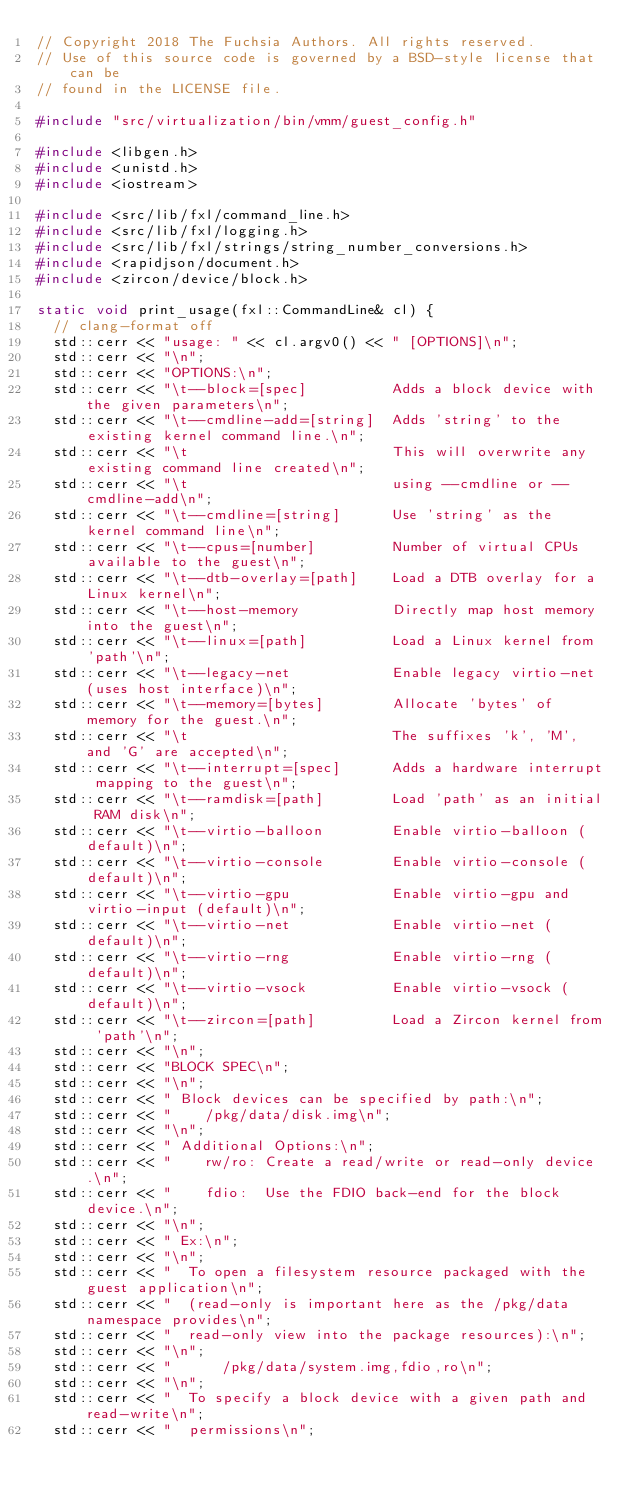Convert code to text. <code><loc_0><loc_0><loc_500><loc_500><_C++_>// Copyright 2018 The Fuchsia Authors. All rights reserved.
// Use of this source code is governed by a BSD-style license that can be
// found in the LICENSE file.

#include "src/virtualization/bin/vmm/guest_config.h"

#include <libgen.h>
#include <unistd.h>
#include <iostream>

#include <src/lib/fxl/command_line.h>
#include <src/lib/fxl/logging.h>
#include <src/lib/fxl/strings/string_number_conversions.h>
#include <rapidjson/document.h>
#include <zircon/device/block.h>

static void print_usage(fxl::CommandLine& cl) {
  // clang-format off
  std::cerr << "usage: " << cl.argv0() << " [OPTIONS]\n";
  std::cerr << "\n";
  std::cerr << "OPTIONS:\n";
  std::cerr << "\t--block=[spec]          Adds a block device with the given parameters\n";
  std::cerr << "\t--cmdline-add=[string]  Adds 'string' to the existing kernel command line.\n";
  std::cerr << "\t                        This will overwrite any existing command line created\n";
  std::cerr << "\t                        using --cmdline or --cmdline-add\n";
  std::cerr << "\t--cmdline=[string]      Use 'string' as the kernel command line\n";
  std::cerr << "\t--cpus=[number]         Number of virtual CPUs available to the guest\n";
  std::cerr << "\t--dtb-overlay=[path]    Load a DTB overlay for a Linux kernel\n";
  std::cerr << "\t--host-memory           Directly map host memory into the guest\n";
  std::cerr << "\t--linux=[path]          Load a Linux kernel from 'path'\n";
  std::cerr << "\t--legacy-net            Enable legacy virtio-net (uses host interface)\n";
  std::cerr << "\t--memory=[bytes]        Allocate 'bytes' of memory for the guest.\n";
  std::cerr << "\t                        The suffixes 'k', 'M', and 'G' are accepted\n";
  std::cerr << "\t--interrupt=[spec]      Adds a hardware interrupt mapping to the guest\n";
  std::cerr << "\t--ramdisk=[path]        Load 'path' as an initial RAM disk\n";
  std::cerr << "\t--virtio-balloon        Enable virtio-balloon (default)\n";
  std::cerr << "\t--virtio-console        Enable virtio-console (default)\n";
  std::cerr << "\t--virtio-gpu            Enable virtio-gpu and virtio-input (default)\n";
  std::cerr << "\t--virtio-net            Enable virtio-net (default)\n";
  std::cerr << "\t--virtio-rng            Enable virtio-rng (default)\n";
  std::cerr << "\t--virtio-vsock          Enable virtio-vsock (default)\n";
  std::cerr << "\t--zircon=[path]         Load a Zircon kernel from 'path'\n";
  std::cerr << "\n";
  std::cerr << "BLOCK SPEC\n";
  std::cerr << "\n";
  std::cerr << " Block devices can be specified by path:\n";
  std::cerr << "    /pkg/data/disk.img\n";
  std::cerr << "\n";
  std::cerr << " Additional Options:\n";
  std::cerr << "    rw/ro: Create a read/write or read-only device.\n";
  std::cerr << "    fdio:  Use the FDIO back-end for the block device.\n";
  std::cerr << "\n";
  std::cerr << " Ex:\n";
  std::cerr << "\n";
  std::cerr << "  To open a filesystem resource packaged with the guest application\n";
  std::cerr << "  (read-only is important here as the /pkg/data namespace provides\n";
  std::cerr << "  read-only view into the package resources):\n";
  std::cerr << "\n";
  std::cerr << "      /pkg/data/system.img,fdio,ro\n";
  std::cerr << "\n";
  std::cerr << "  To specify a block device with a given path and read-write\n";
  std::cerr << "  permissions\n";</code> 